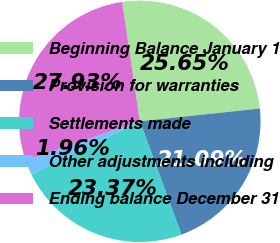Convert chart to OTSL. <chart><loc_0><loc_0><loc_500><loc_500><pie_chart><fcel>Beginning Balance January 1<fcel>Provision for warranties<fcel>Settlements made<fcel>Other adjustments including<fcel>Ending balance December 31<nl><fcel>25.65%<fcel>21.09%<fcel>23.37%<fcel>1.96%<fcel>27.93%<nl></chart> 